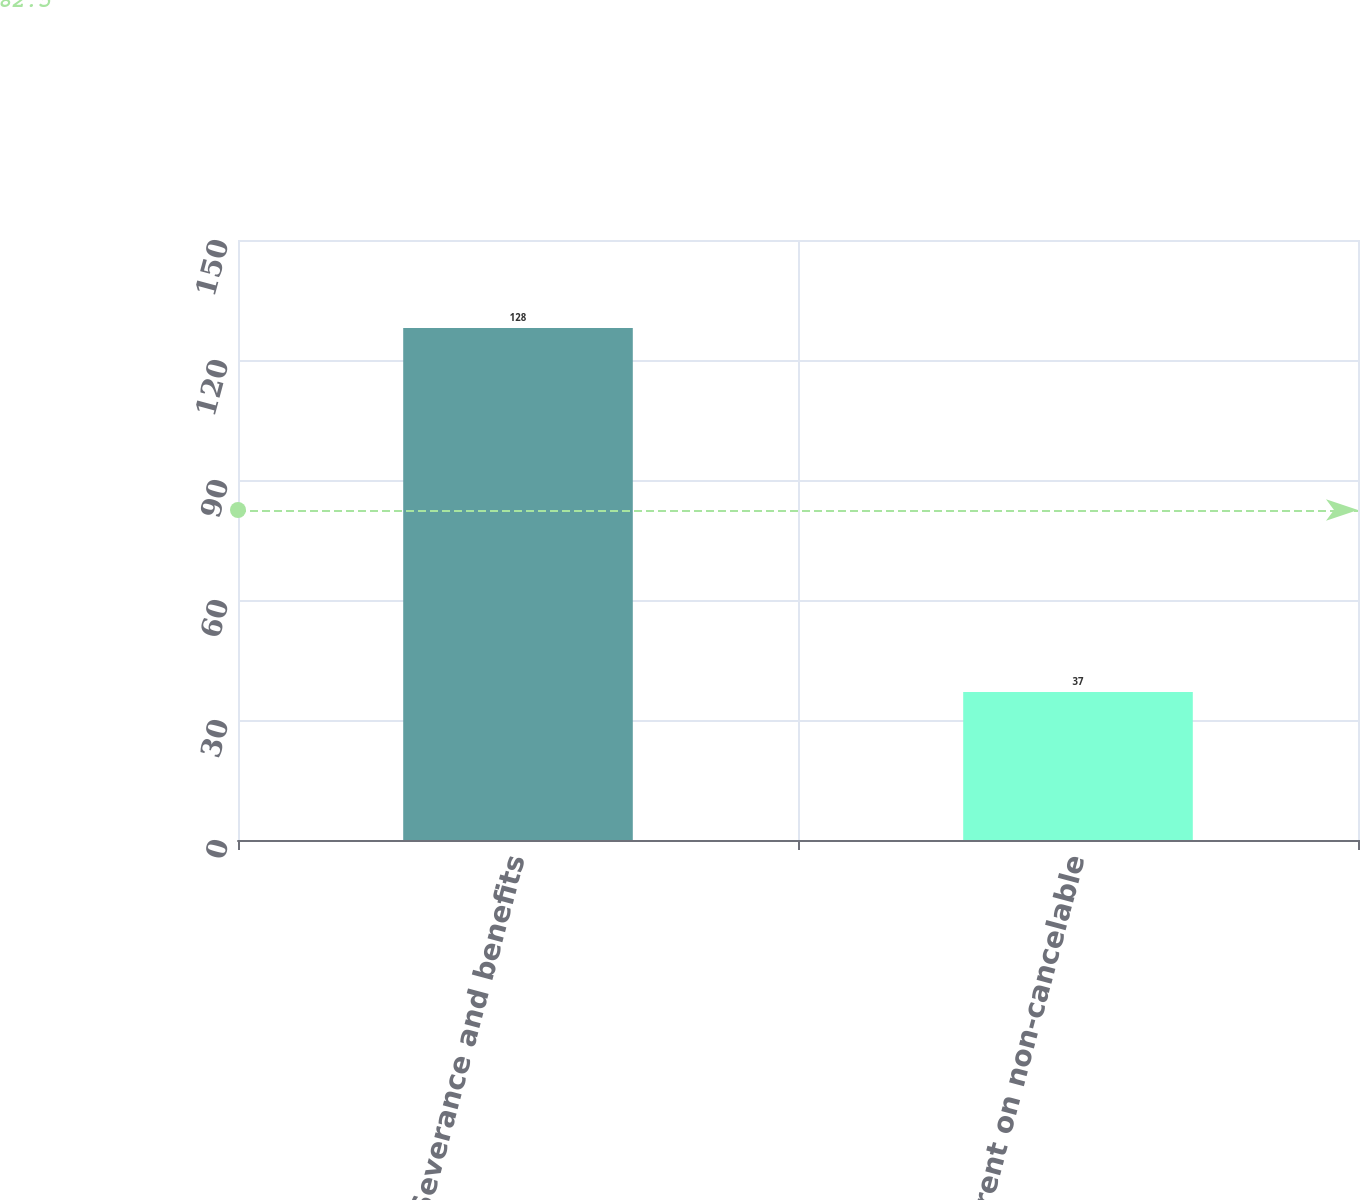<chart> <loc_0><loc_0><loc_500><loc_500><bar_chart><fcel>Severance and benefits<fcel>Future rent on non-cancelable<nl><fcel>128<fcel>37<nl></chart> 